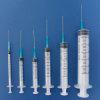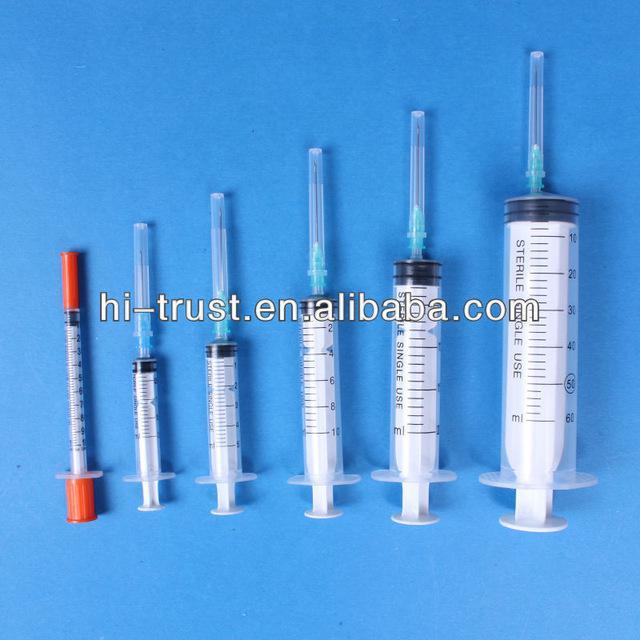The first image is the image on the left, the second image is the image on the right. Given the left and right images, does the statement "Each image contains more than four syringes." hold true? Answer yes or no. Yes. The first image is the image on the left, the second image is the image on the right. Evaluate the accuracy of this statement regarding the images: "In one of the images, there are no needles attached to the syringes.". Is it true? Answer yes or no. No. 